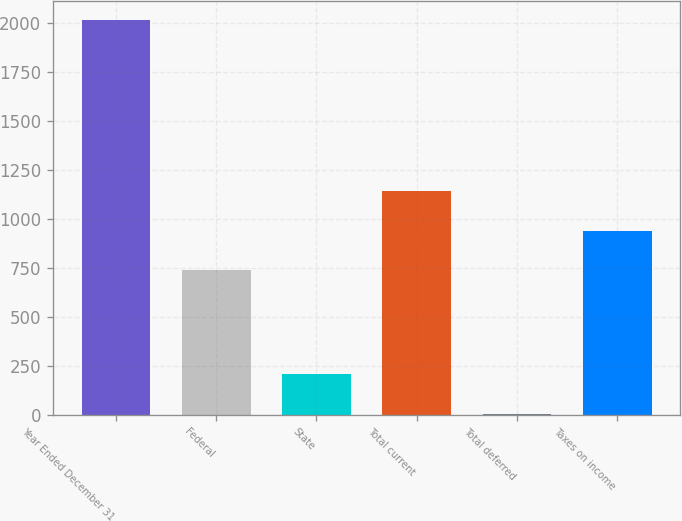Convert chart to OTSL. <chart><loc_0><loc_0><loc_500><loc_500><bar_chart><fcel>Year Ended December 31<fcel>Federal<fcel>State<fcel>Total current<fcel>Total deferred<fcel>Taxes on income<nl><fcel>2015<fcel>740<fcel>207.8<fcel>1141.6<fcel>7<fcel>940.8<nl></chart> 